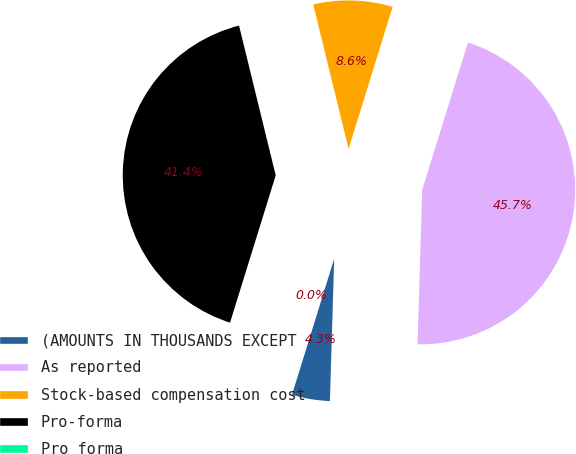<chart> <loc_0><loc_0><loc_500><loc_500><pie_chart><fcel>(AMOUNTS IN THOUSANDS EXCEPT<fcel>As reported<fcel>Stock-based compensation cost<fcel>Pro-forma<fcel>Pro forma<nl><fcel>4.31%<fcel>45.69%<fcel>8.61%<fcel>41.39%<fcel>0.0%<nl></chart> 